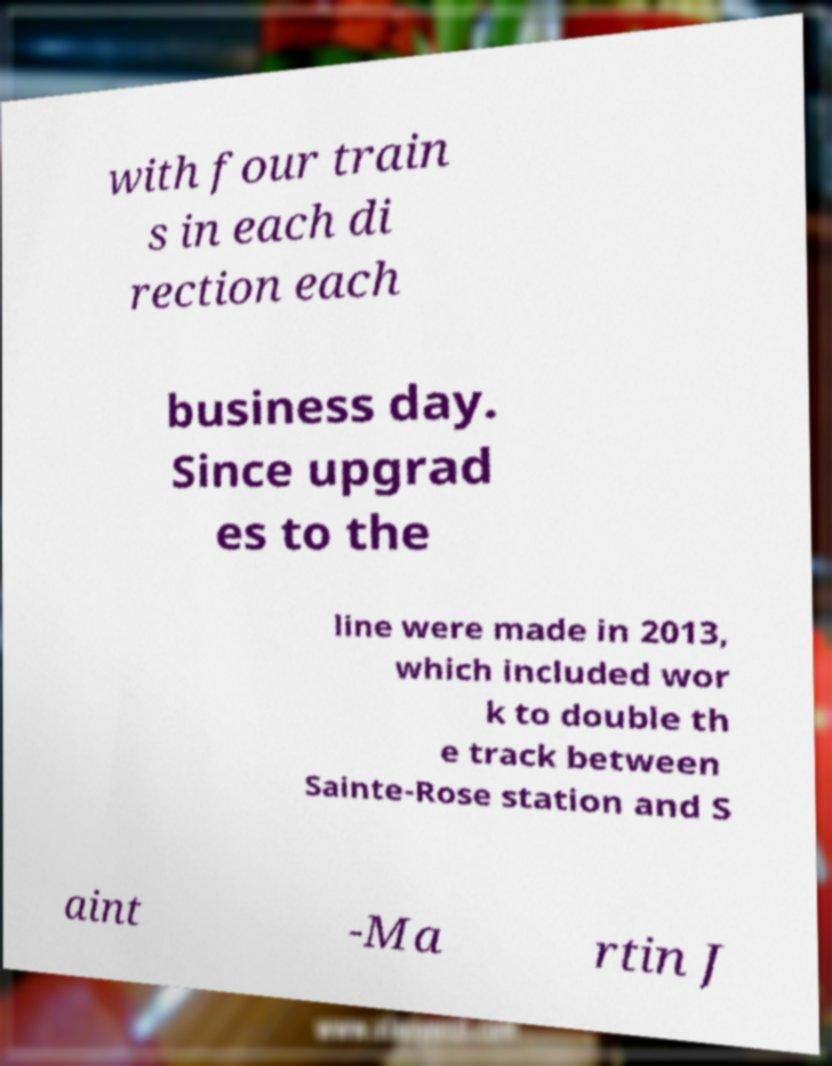Can you read and provide the text displayed in the image?This photo seems to have some interesting text. Can you extract and type it out for me? with four train s in each di rection each business day. Since upgrad es to the line were made in 2013, which included wor k to double th e track between Sainte-Rose station and S aint -Ma rtin J 